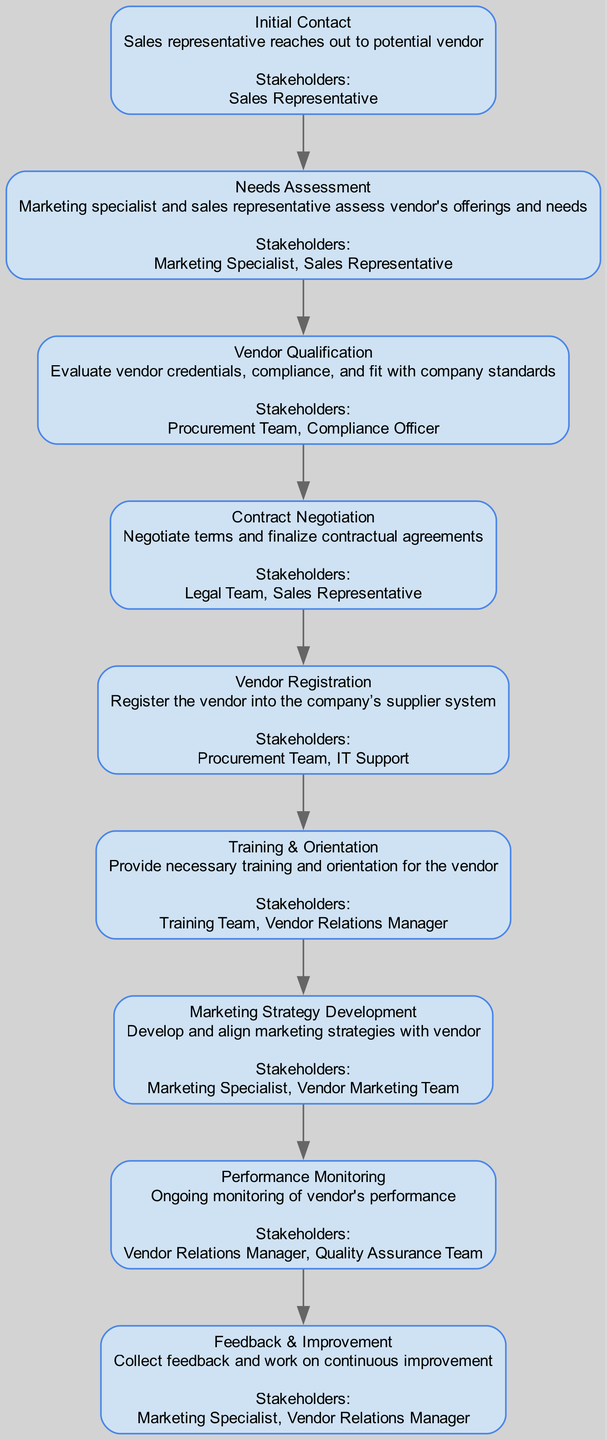what is the first step in the vendor onboarding process? The first step listed in the diagram is "Initial Contact," which is when the sales representative reaches out to a potential vendor. This information is gathered from the first node.
Answer: Initial Contact how many stakeholders are involved in the "Vendor Qualification" step? The "Vendor Qualification" step lists two stakeholders: the Procurement Team and the Compliance Officer. By counting the stakeholders mentioned in this node, we find there are two.
Answer: 2 which stakeholder is responsible for "Marketing Strategy Development"? In the "Marketing Strategy Development" step, the stakeholders listed are the Marketing Specialist and the Vendor Marketing Team. The Marketing Specialist is specifically named, so they are a key stakeholder.
Answer: Marketing Specialist what is the last step in the process flow? The last step in the diagram is "Feedback & Improvement." This can be identified by looking at the final node in the sequence of steps.
Answer: Feedback & Improvement how many steps are there in the vendor onboarding process? The diagram lists a total of nine steps involved in the vendor onboarding process, which can be counted directly from the listed steps.
Answer: 9 which teams are involved in the "Training & Orientation" step? The "Training & Orientation" step mentions two teams as stakeholders: the Training Team and the Vendor Relations Manager. This can be determined by looking through the node to see the mentioned stakeholders.
Answer: Training Team, Vendor Relations Manager which step comes after "Contract Negotiation"? The step following "Contract Negotiation" is "Vendor Registration." By tracing the flow from the Contract Negotiation node, we identify the next step in sequence.
Answer: Vendor Registration are the Marketing Specialist and Sales Representative involved in "Needs Assessment"? Yes, both the Marketing Specialist and the Sales Representative are identified as stakeholders in the "Needs Assessment" step. This is directly noted in the corresponding node in the diagram.
Answer: Yes 